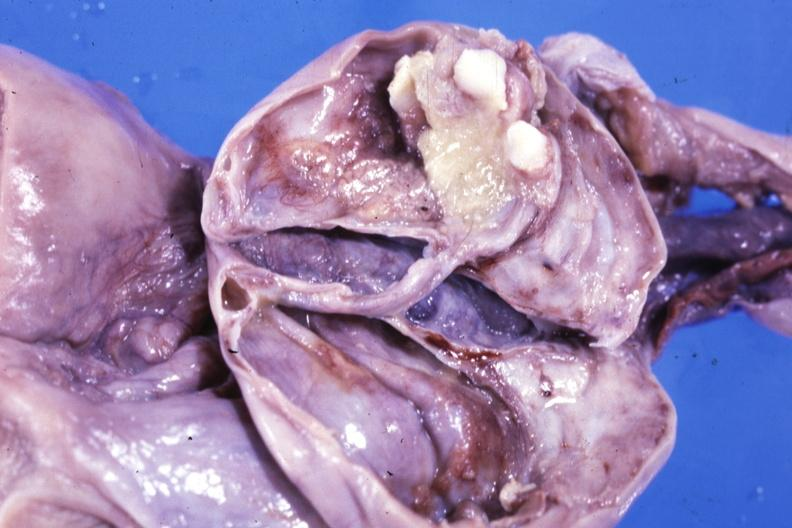where does this part belong to?
Answer the question using a single word or phrase. Female reproductive system 